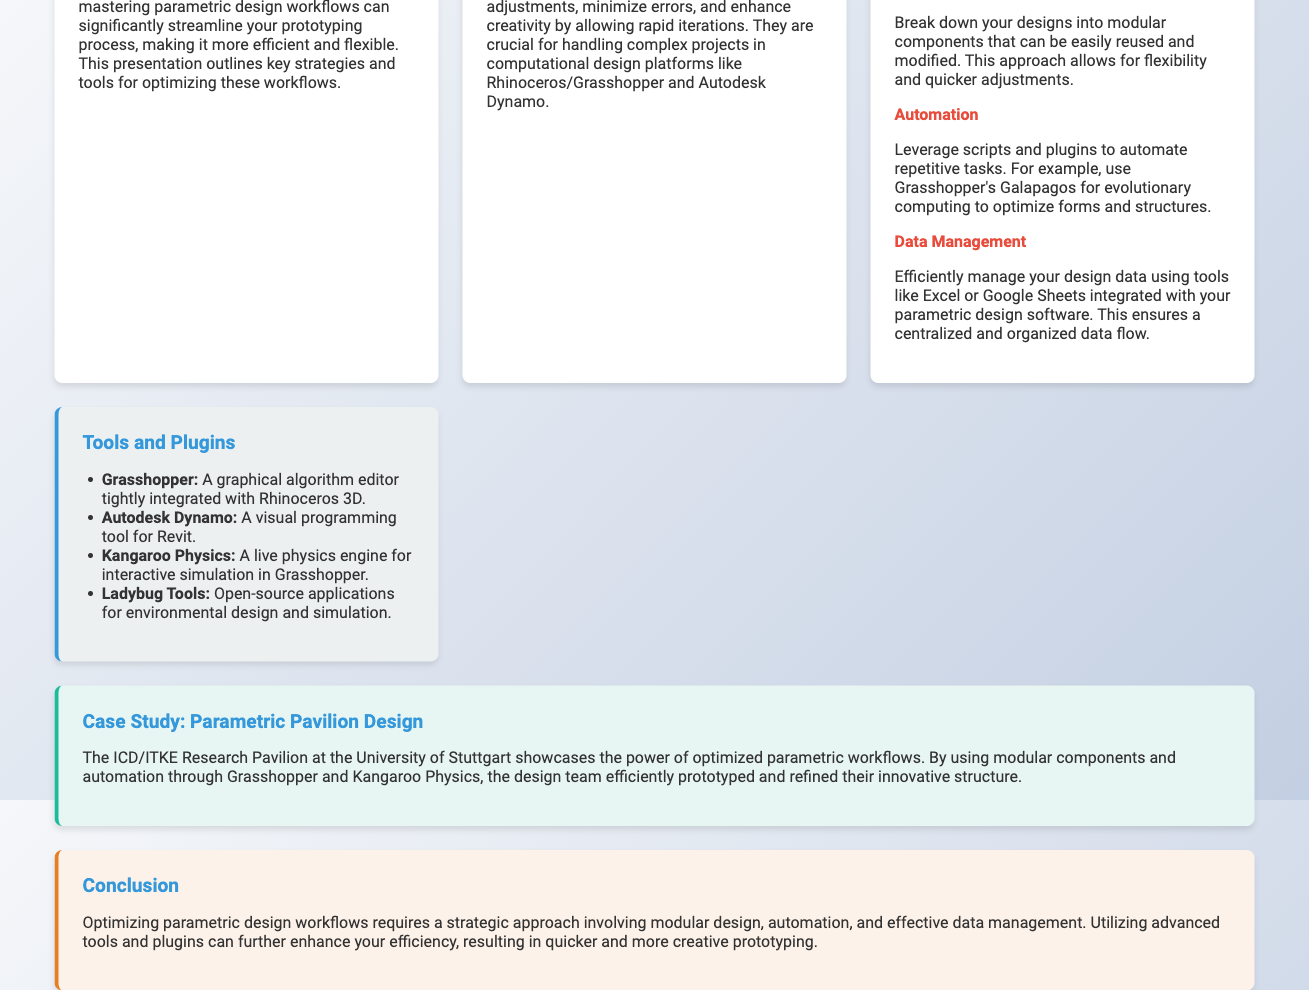What is the title of the presentation? The title is provided in the main heading of the document.
Answer: Optimizing Parametric Design Workflows for Efficient Prototyping What design software is mentioned for parametric design? The document mentions specific software used in parametric design workflows.
Answer: Rhinoceros/Grasshopper What is one key strategy mentioned for optimizing workflows? The document lists several key strategies for optimizing parametric design workflows.
Answer: Modular Design Which tool is associated with visual programming for Revit? The document specifically identifies tools relevant to parametric design.
Answer: Autodesk Dynamo What is the color of the section highlighting tools and plugins? The background color of each section is specified in the document's styling.
Answer: Light grey How does modular design benefit prototyping? The document explains the advantages of modular design, prompting reasoning based on its content.
Answer: Flexibility What is the case study highlighted in the presentation? The document outlines a specific example of optimized parametric workflows.
Answer: Parametric Pavilion Design What scripting tool does Grasshopper offer for evolutionary computing? An example of automation tools is mentioned in the document.
Answer: Galapagos What is the primary advantage of optimizing workflows mentioned in the document? The document sums up the main benefits of efficient workflows.
Answer: Enhanced creativity 